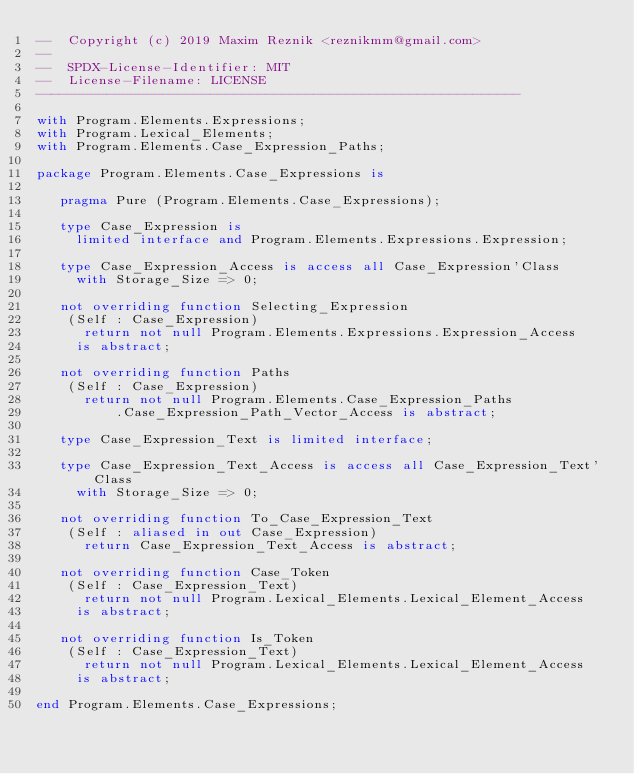<code> <loc_0><loc_0><loc_500><loc_500><_Ada_>--  Copyright (c) 2019 Maxim Reznik <reznikmm@gmail.com>
--
--  SPDX-License-Identifier: MIT
--  License-Filename: LICENSE
-------------------------------------------------------------

with Program.Elements.Expressions;
with Program.Lexical_Elements;
with Program.Elements.Case_Expression_Paths;

package Program.Elements.Case_Expressions is

   pragma Pure (Program.Elements.Case_Expressions);

   type Case_Expression is
     limited interface and Program.Elements.Expressions.Expression;

   type Case_Expression_Access is access all Case_Expression'Class
     with Storage_Size => 0;

   not overriding function Selecting_Expression
    (Self : Case_Expression)
      return not null Program.Elements.Expressions.Expression_Access
     is abstract;

   not overriding function Paths
    (Self : Case_Expression)
      return not null Program.Elements.Case_Expression_Paths
          .Case_Expression_Path_Vector_Access is abstract;

   type Case_Expression_Text is limited interface;

   type Case_Expression_Text_Access is access all Case_Expression_Text'Class
     with Storage_Size => 0;

   not overriding function To_Case_Expression_Text
    (Self : aliased in out Case_Expression)
      return Case_Expression_Text_Access is abstract;

   not overriding function Case_Token
    (Self : Case_Expression_Text)
      return not null Program.Lexical_Elements.Lexical_Element_Access
     is abstract;

   not overriding function Is_Token
    (Self : Case_Expression_Text)
      return not null Program.Lexical_Elements.Lexical_Element_Access
     is abstract;

end Program.Elements.Case_Expressions;
</code> 